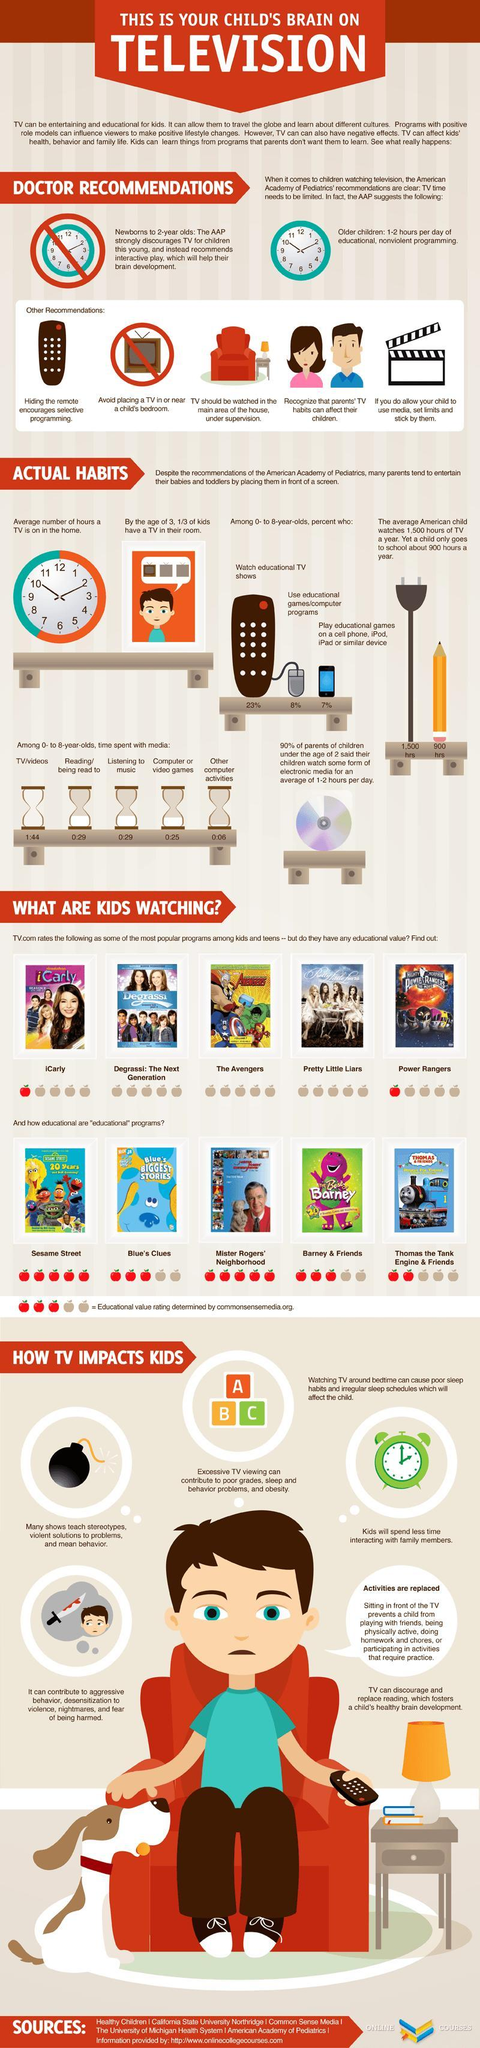What percent of children aged 0-8 years use educational games/computer programs in America?
Answer the question with a short phrase. 8% What percent of children aged 0-8 years watch educational TV shows in America? 23% 